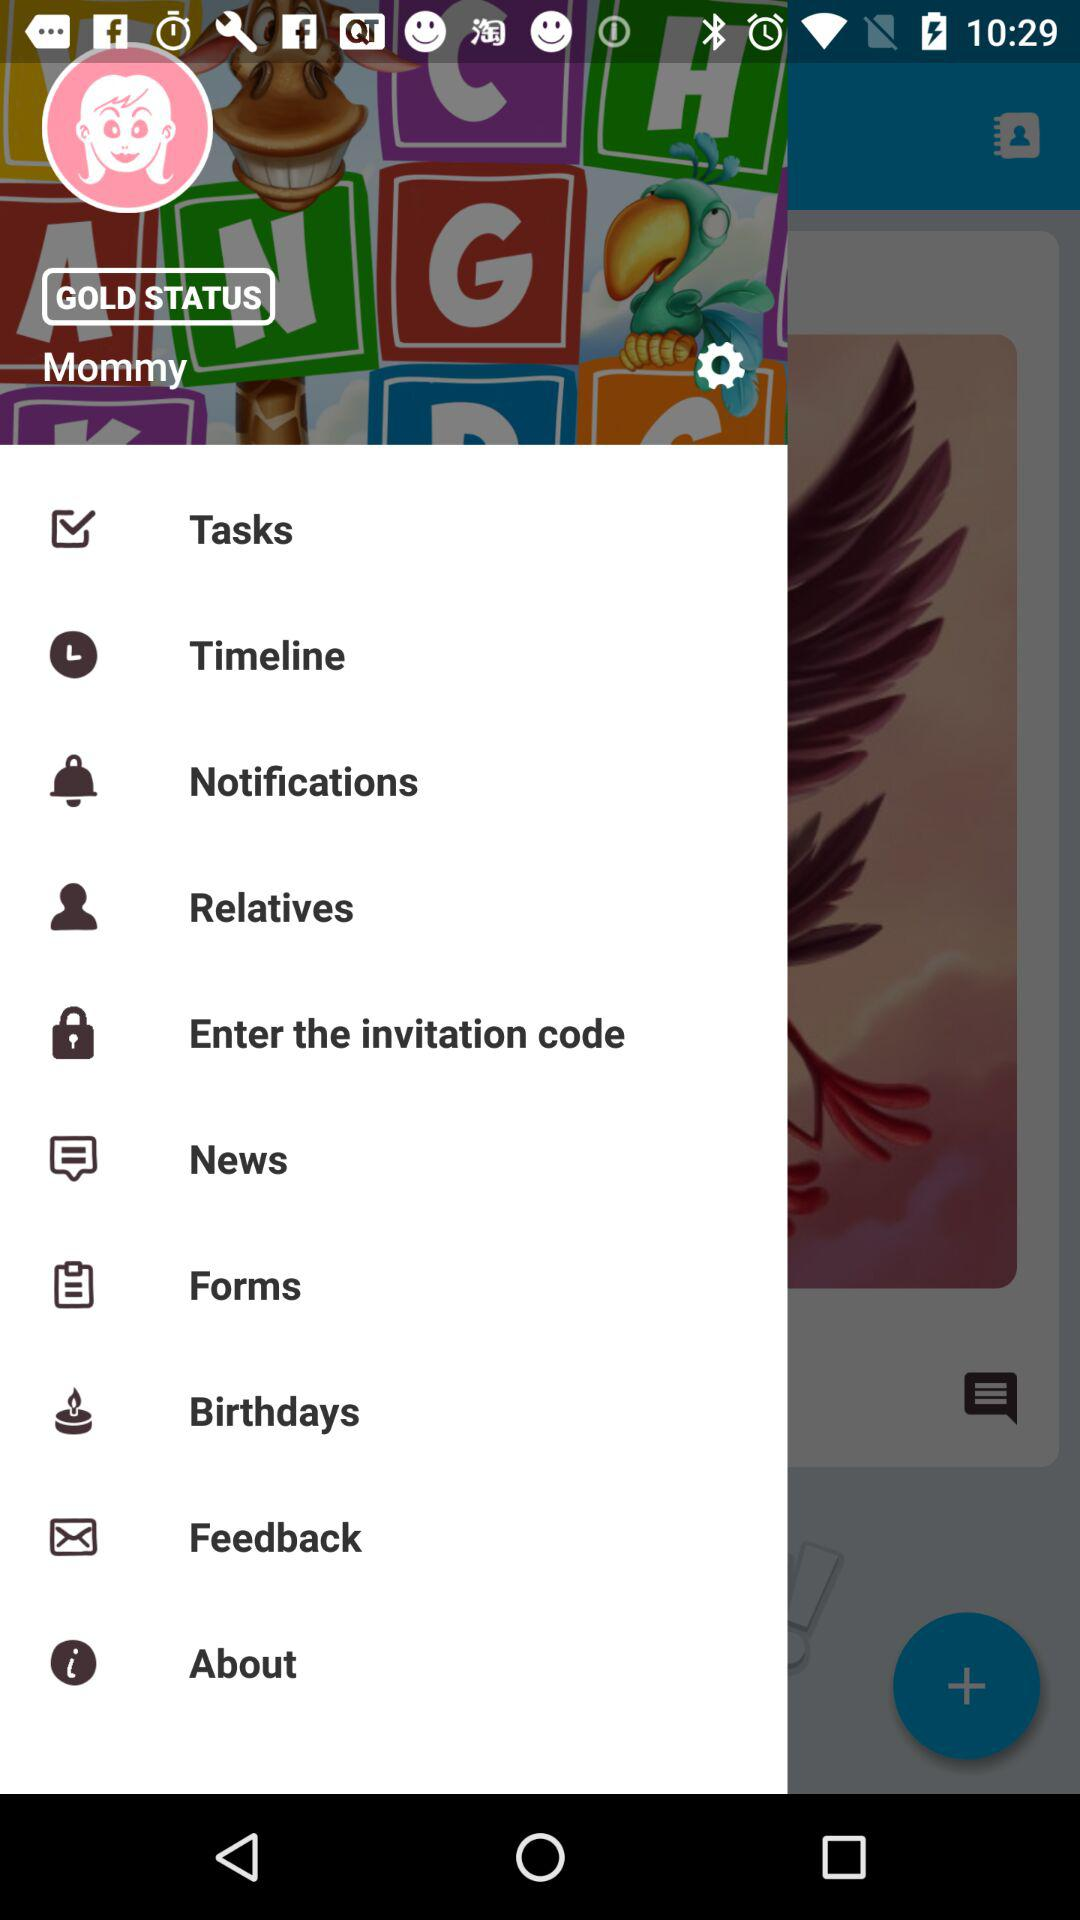What's the Gold Status?
When the provided information is insufficient, respond with <no answer>. <no answer> 